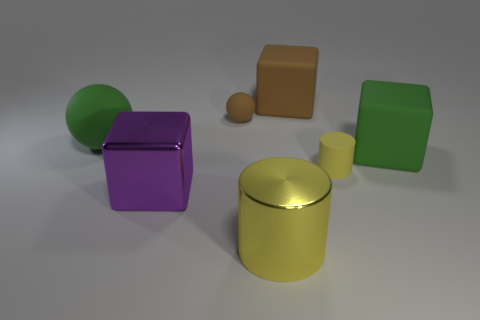How do the objects in the image appear in terms of lighting and texture? The objects exhibit different textures and are affected by the lighting in unique ways. The yellow cylinder has a shiny surface reflecting the light, making it appear metallic. The purple cube seems to have a smoother, possibly plastic-like finish. The green shapes have a matte texture, diffusing the light softly, while the orange cuboid and small brown sphere have more muted reflections, suggesting a less reflective material. Does the lighting reveal anything about the environment? The shadows cast by the objects suggest that the light source is positioned above them, possibly indicating an indoor setting such as a studio. The careful placement of the objects and the neutral background hint at a controlled environment, specifically set up for display or photography. 